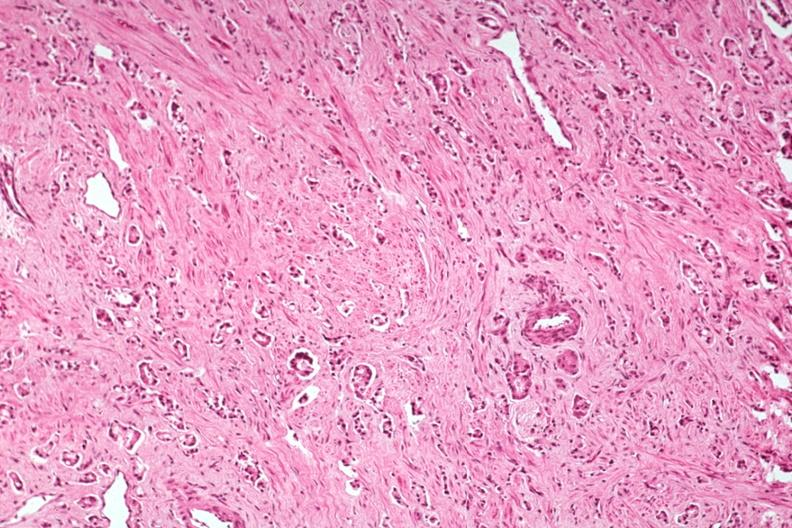what is present?
Answer the question using a single word or phrase. Adenocarcinoma 